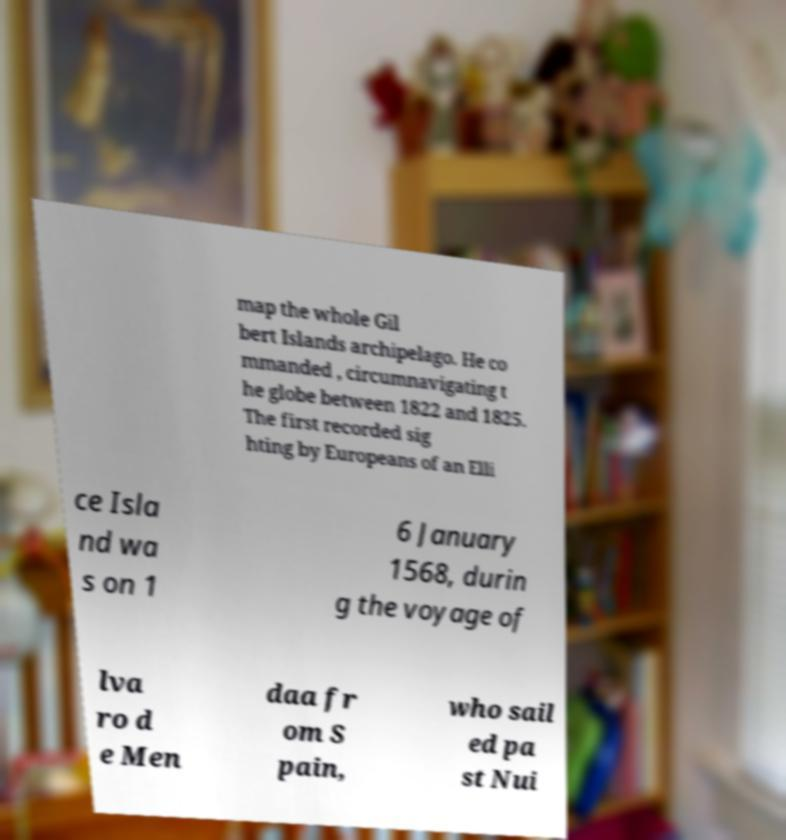Please read and relay the text visible in this image. What does it say? map the whole Gil bert Islands archipelago. He co mmanded , circumnavigating t he globe between 1822 and 1825. The first recorded sig hting by Europeans of an Elli ce Isla nd wa s on 1 6 January 1568, durin g the voyage of lva ro d e Men daa fr om S pain, who sail ed pa st Nui 